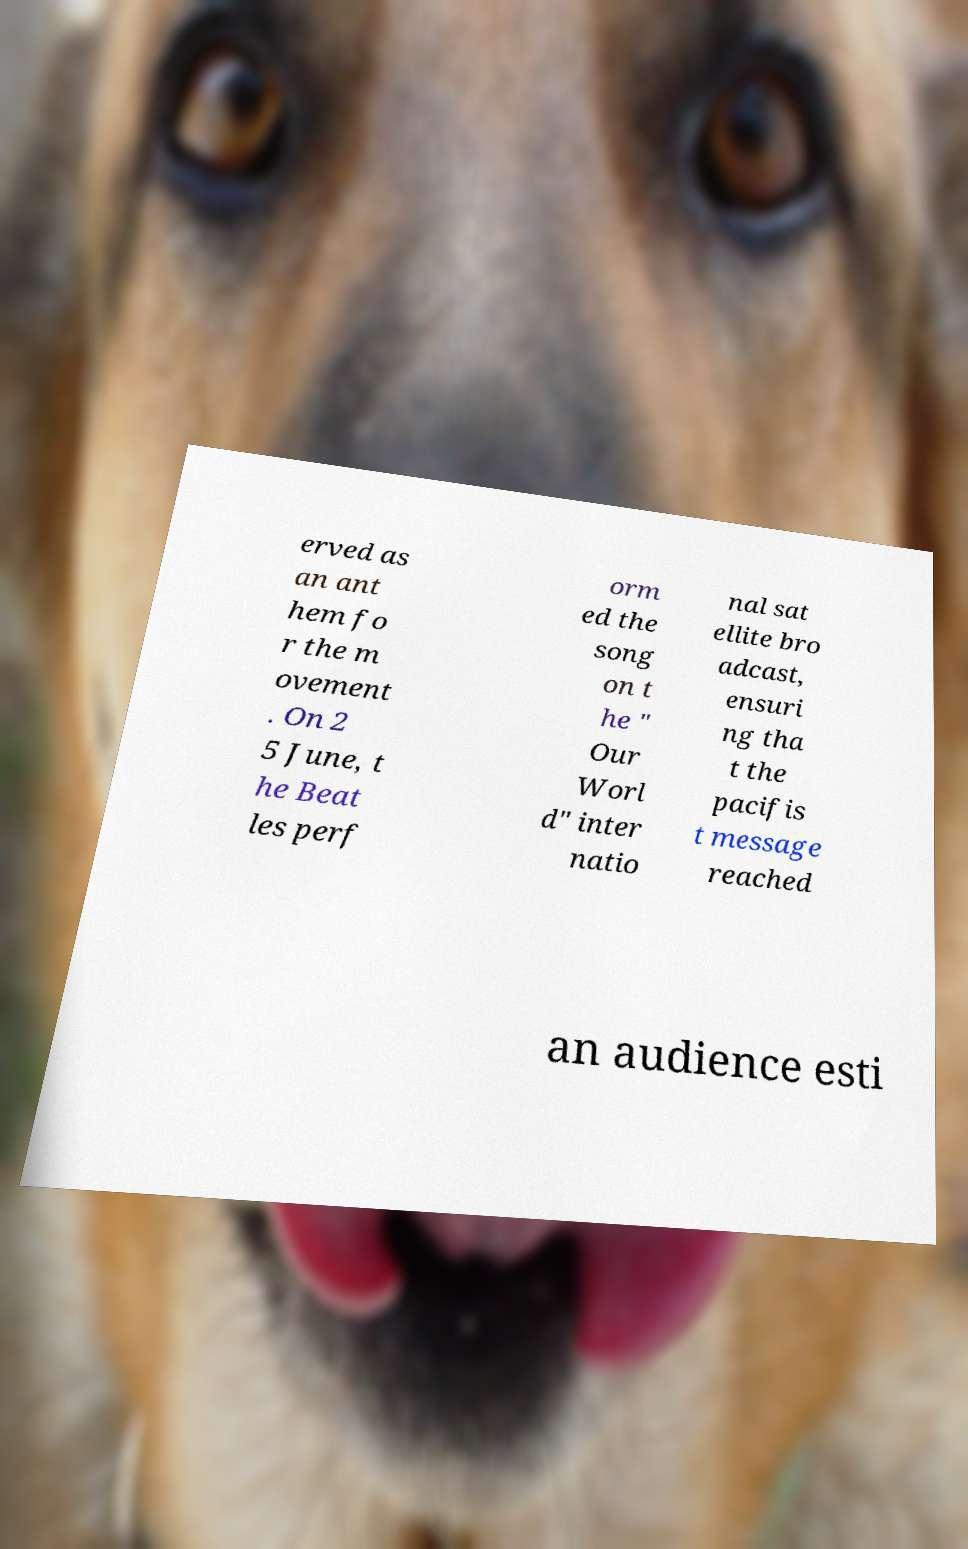What messages or text are displayed in this image? I need them in a readable, typed format. erved as an ant hem fo r the m ovement . On 2 5 June, t he Beat les perf orm ed the song on t he " Our Worl d" inter natio nal sat ellite bro adcast, ensuri ng tha t the pacifis t message reached an audience esti 